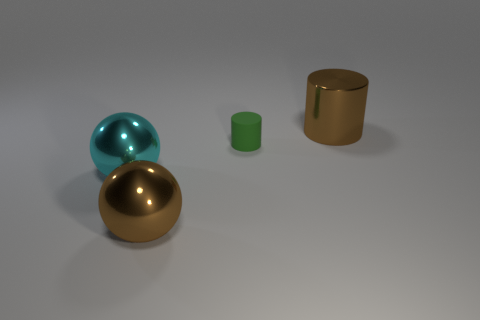Add 4 yellow rubber spheres. How many objects exist? 8 Subtract all brown cylinders. How many cylinders are left? 1 Subtract 1 spheres. How many spheres are left? 1 Subtract all gray cylinders. Subtract all yellow balls. How many cylinders are left? 2 Subtract all big gray metal cylinders. Subtract all cyan shiny objects. How many objects are left? 3 Add 3 brown shiny spheres. How many brown shiny spheres are left? 4 Add 3 tiny green rubber things. How many tiny green rubber things exist? 4 Subtract 0 purple cylinders. How many objects are left? 4 